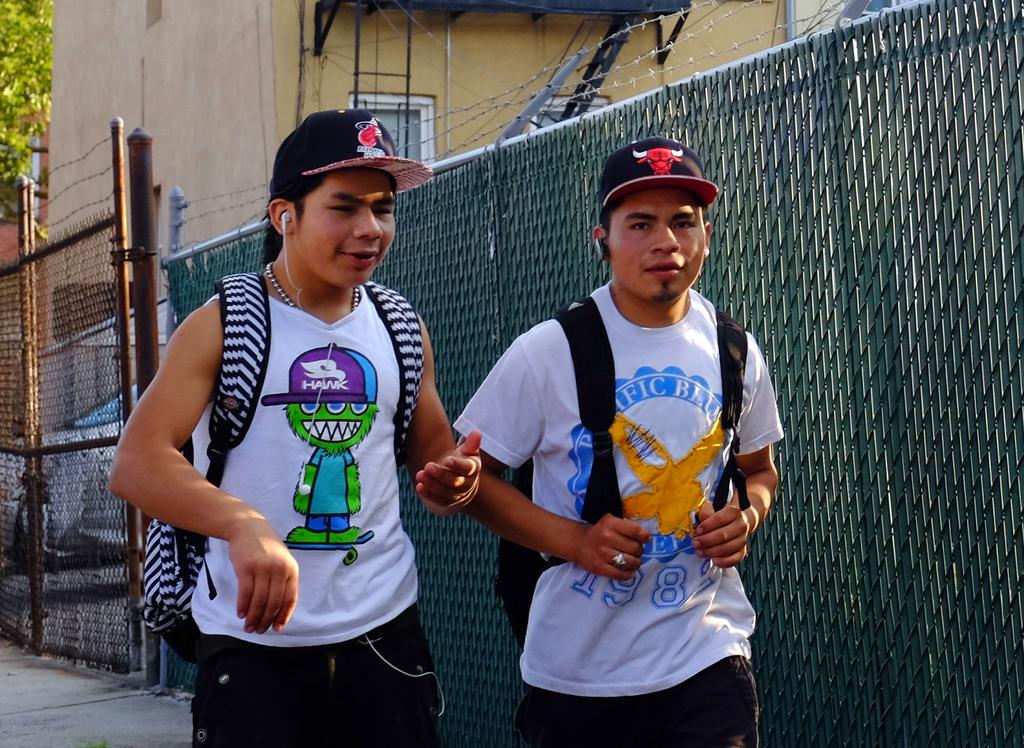<image>
Provide a brief description of the given image. Two boys with backpacks are walking by a fence and one of their shirts says Hawk. 